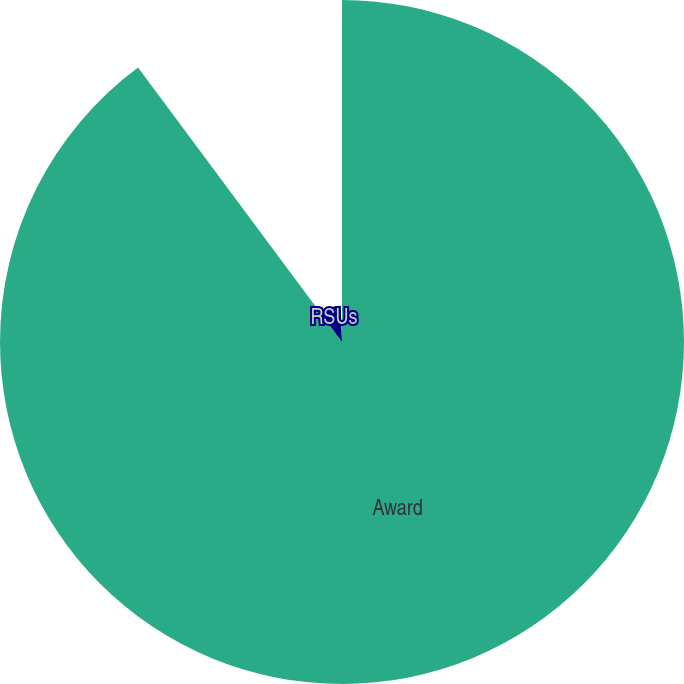Convert chart to OTSL. <chart><loc_0><loc_0><loc_500><loc_500><pie_chart><fcel>Award<fcel>RSUs<fcel>MSUs<nl><fcel>89.83%<fcel>9.55%<fcel>0.62%<nl></chart> 